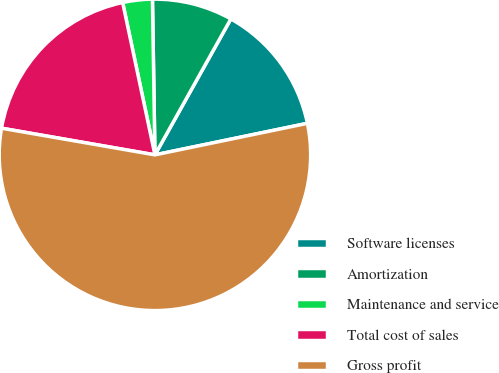Convert chart. <chart><loc_0><loc_0><loc_500><loc_500><pie_chart><fcel>Software licenses<fcel>Amortization<fcel>Maintenance and service<fcel>Total cost of sales<fcel>Gross profit<nl><fcel>13.65%<fcel>8.36%<fcel>3.07%<fcel>18.94%<fcel>55.99%<nl></chart> 